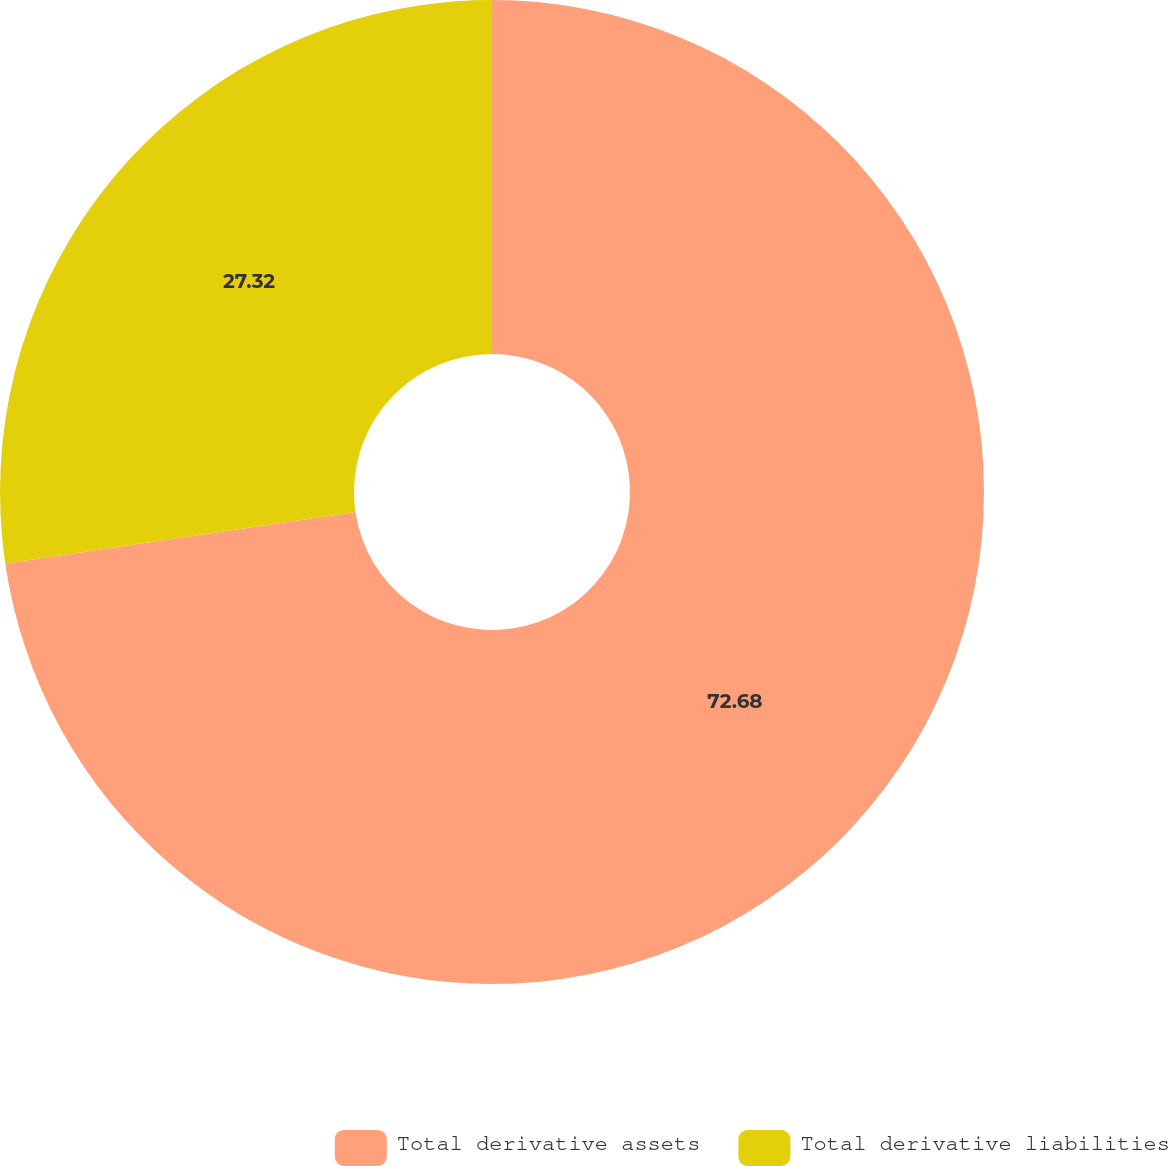Convert chart. <chart><loc_0><loc_0><loc_500><loc_500><pie_chart><fcel>Total derivative assets<fcel>Total derivative liabilities<nl><fcel>72.68%<fcel>27.32%<nl></chart> 